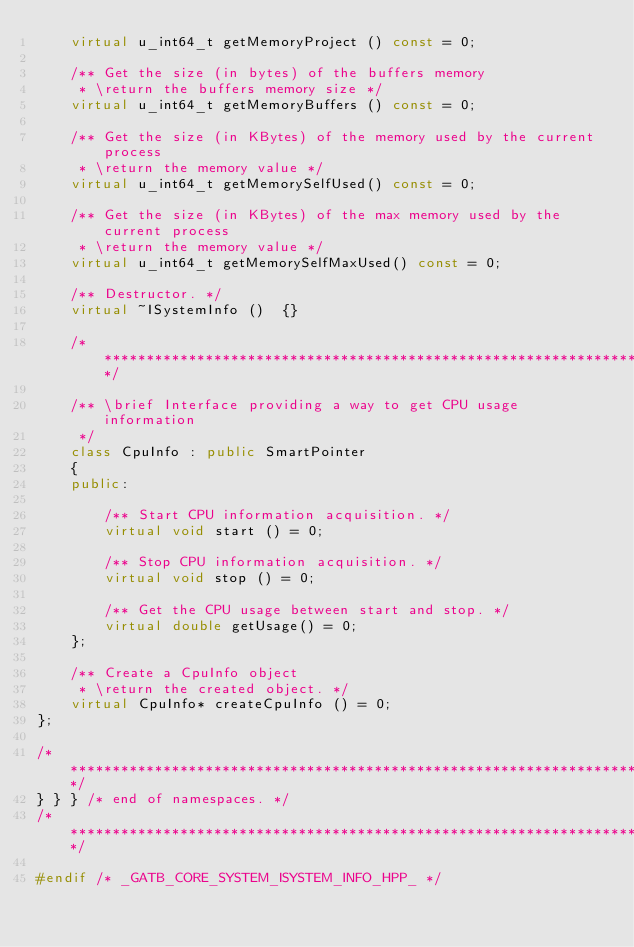Convert code to text. <code><loc_0><loc_0><loc_500><loc_500><_C++_>    virtual u_int64_t getMemoryProject () const = 0;

    /** Get the size (in bytes) of the buffers memory
     * \return the buffers memory size */
    virtual u_int64_t getMemoryBuffers () const = 0;

    /** Get the size (in KBytes) of the memory used by the current process
     * \return the memory value */
    virtual u_int64_t getMemorySelfUsed() const = 0;

    /** Get the size (in KBytes) of the max memory used by the current process
     * \return the memory value */
    virtual u_int64_t getMemorySelfMaxUsed() const = 0;

    /** Destructor. */
    virtual ~ISystemInfo ()  {}

    /********************************************************************************/

    /** \brief Interface providing a way to get CPU usage information
     */
    class CpuInfo : public SmartPointer
    {
    public:

        /** Start CPU information acquisition. */
        virtual void start () = 0;

        /** Stop CPU information acquisition. */
        virtual void stop () = 0;

        /** Get the CPU usage between start and stop. */
        virtual double getUsage() = 0;
    };

    /** Create a CpuInfo object
     * \return the created object. */
    virtual CpuInfo* createCpuInfo () = 0;
};

/********************************************************************************/
} } } /* end of namespaces. */
/********************************************************************************/

#endif /* _GATB_CORE_SYSTEM_ISYSTEM_INFO_HPP_ */
</code> 